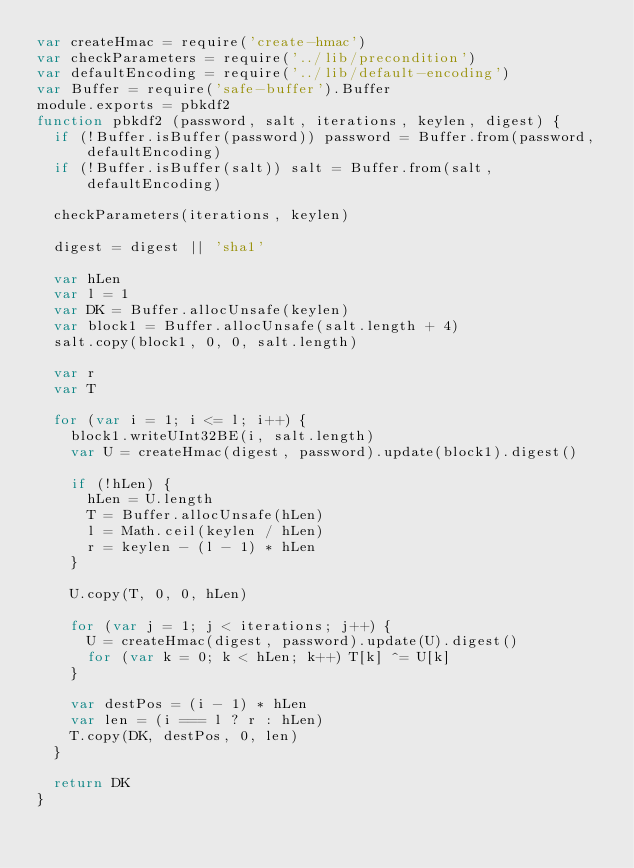Convert code to text. <code><loc_0><loc_0><loc_500><loc_500><_JavaScript_>var createHmac = require('create-hmac')
var checkParameters = require('../lib/precondition')
var defaultEncoding = require('../lib/default-encoding')
var Buffer = require('safe-buffer').Buffer
module.exports = pbkdf2
function pbkdf2 (password, salt, iterations, keylen, digest) {
  if (!Buffer.isBuffer(password)) password = Buffer.from(password, defaultEncoding)
  if (!Buffer.isBuffer(salt)) salt = Buffer.from(salt, defaultEncoding)

  checkParameters(iterations, keylen)

  digest = digest || 'sha1'

  var hLen
  var l = 1
  var DK = Buffer.allocUnsafe(keylen)
  var block1 = Buffer.allocUnsafe(salt.length + 4)
  salt.copy(block1, 0, 0, salt.length)

  var r
  var T

  for (var i = 1; i <= l; i++) {
    block1.writeUInt32BE(i, salt.length)
    var U = createHmac(digest, password).update(block1).digest()

    if (!hLen) {
      hLen = U.length
      T = Buffer.allocUnsafe(hLen)
      l = Math.ceil(keylen / hLen)
      r = keylen - (l - 1) * hLen
    }

    U.copy(T, 0, 0, hLen)

    for (var j = 1; j < iterations; j++) {
      U = createHmac(digest, password).update(U).digest()
      for (var k = 0; k < hLen; k++) T[k] ^= U[k]
    }

    var destPos = (i - 1) * hLen
    var len = (i === l ? r : hLen)
    T.copy(DK, destPos, 0, len)
  }

  return DK
}
</code> 